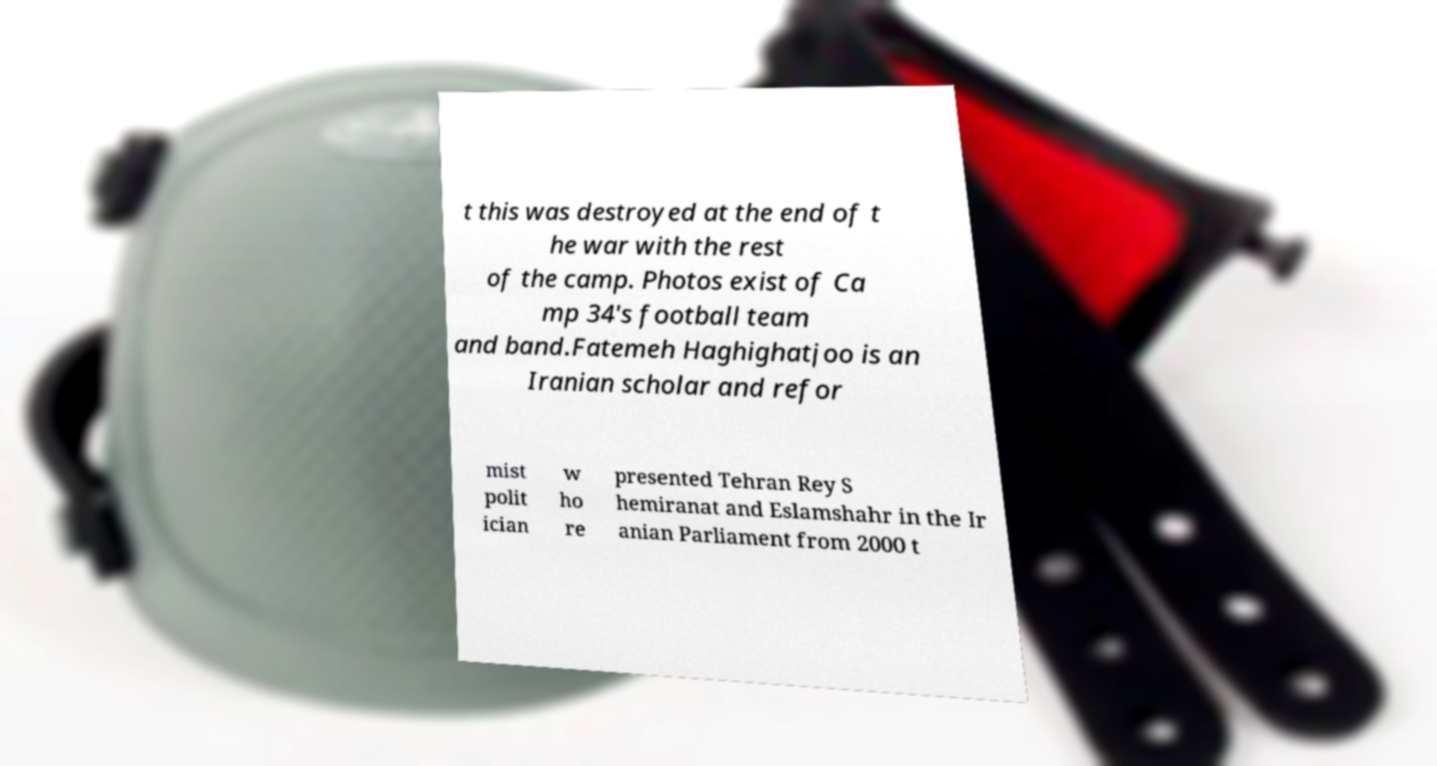Can you accurately transcribe the text from the provided image for me? t this was destroyed at the end of t he war with the rest of the camp. Photos exist of Ca mp 34's football team and band.Fatemeh Haghighatjoo is an Iranian scholar and refor mist polit ician w ho re presented Tehran Rey S hemiranat and Eslamshahr in the Ir anian Parliament from 2000 t 